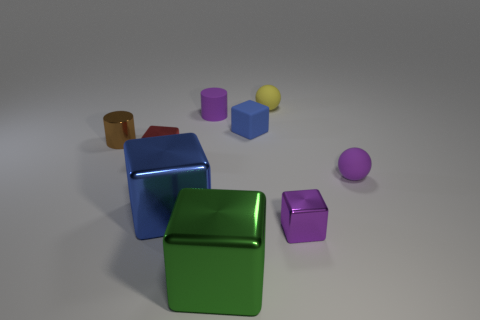What is the shape of the tiny rubber thing that is the same color as the rubber cylinder?
Make the answer very short. Sphere. What number of spheres are either tiny red shiny things or small yellow matte objects?
Give a very brief answer. 1. There is a yellow rubber thing; does it have the same size as the brown metallic cylinder to the left of the small purple rubber ball?
Your answer should be very brief. Yes. Are there more large blue metal cubes behind the small yellow ball than tiny cylinders?
Provide a succinct answer. No. There is a red block that is made of the same material as the green cube; what size is it?
Give a very brief answer. Small. Are there any metal cylinders that have the same color as the matte cylinder?
Keep it short and to the point. No. How many things are small red metal things or objects to the right of the brown thing?
Give a very brief answer. 8. Is the number of rubber blocks greater than the number of things?
Make the answer very short. No. What size is the matte sphere that is the same color as the matte cylinder?
Offer a terse response. Small. Are there any yellow things made of the same material as the brown thing?
Provide a succinct answer. No. 